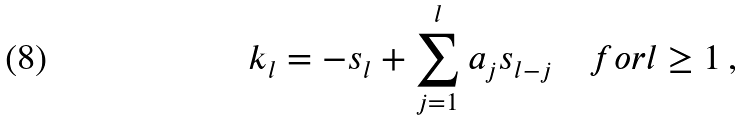Convert formula to latex. <formula><loc_0><loc_0><loc_500><loc_500>k _ { l } = - s _ { l } + \sum _ { j = 1 } ^ { l } a _ { j } s _ { l - j } \quad f o r l \geq 1 \, ,</formula> 